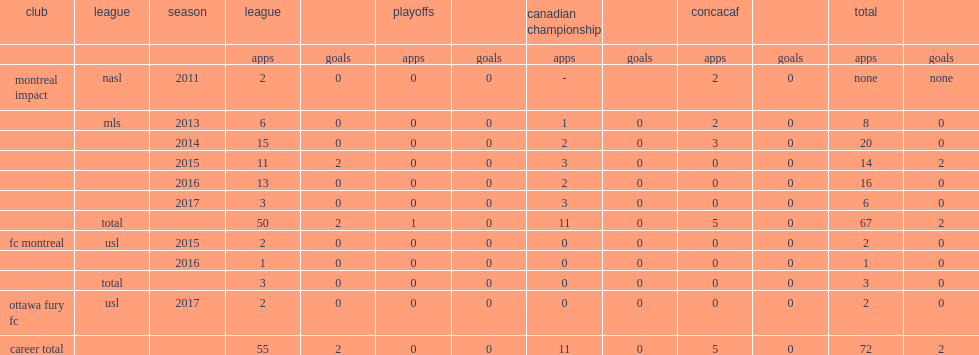When did lefevre make his debut for montreal impact (nasl)? 2011.0. 